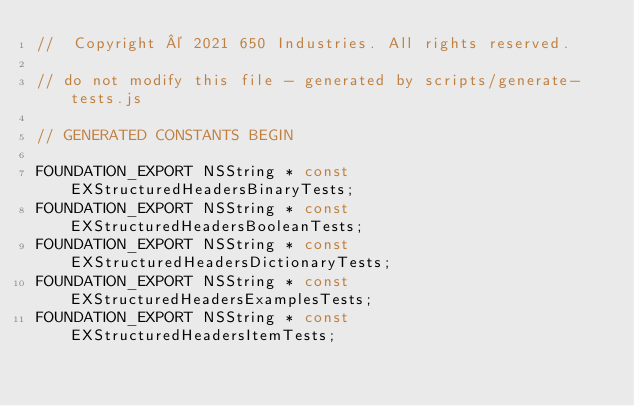Convert code to text. <code><loc_0><loc_0><loc_500><loc_500><_C_>//  Copyright © 2021 650 Industries. All rights reserved.

// do not modify this file - generated by scripts/generate-tests.js

// GENERATED CONSTANTS BEGIN

FOUNDATION_EXPORT NSString * const EXStructuredHeadersBinaryTests;
FOUNDATION_EXPORT NSString * const EXStructuredHeadersBooleanTests;
FOUNDATION_EXPORT NSString * const EXStructuredHeadersDictionaryTests;
FOUNDATION_EXPORT NSString * const EXStructuredHeadersExamplesTests;
FOUNDATION_EXPORT NSString * const EXStructuredHeadersItemTests;</code> 